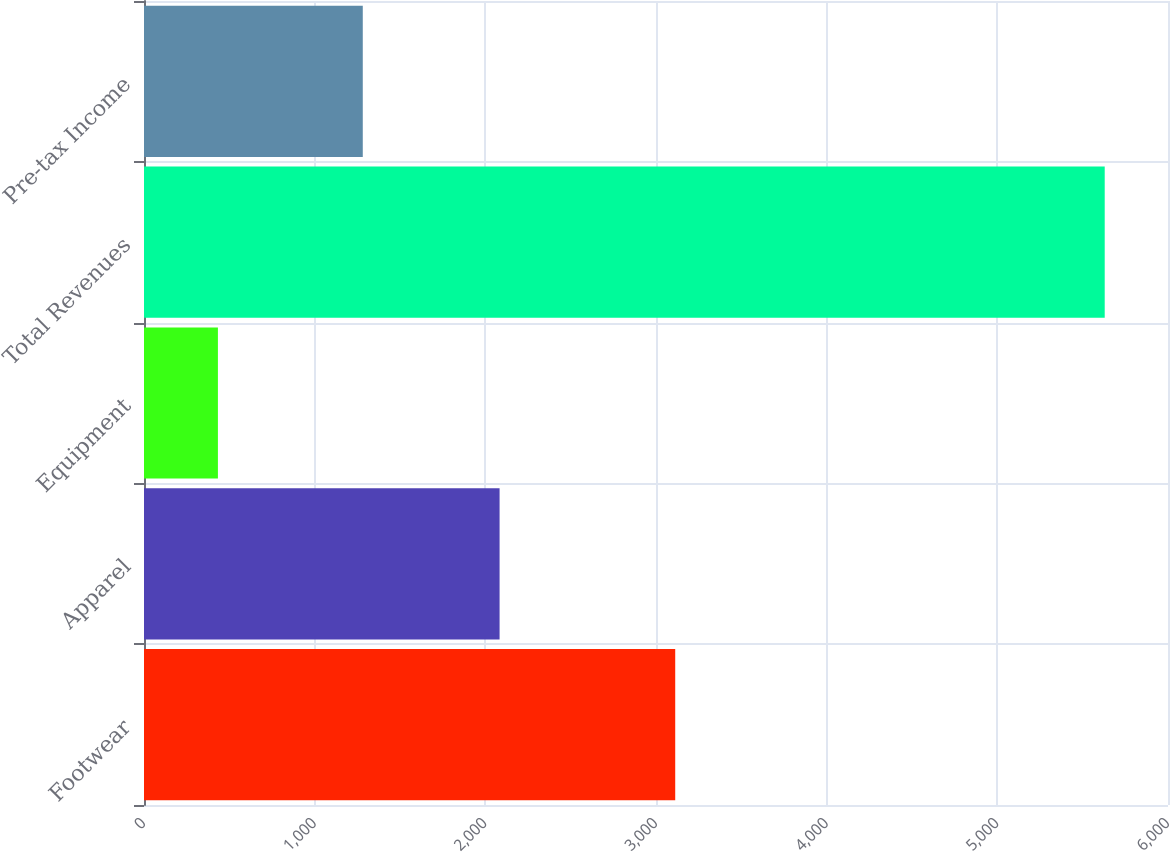Convert chart. <chart><loc_0><loc_0><loc_500><loc_500><bar_chart><fcel>Footwear<fcel>Apparel<fcel>Equipment<fcel>Total Revenues<fcel>Pre-tax Income<nl><fcel>3112.6<fcel>2083.5<fcel>433.1<fcel>5629.2<fcel>1281.9<nl></chart> 